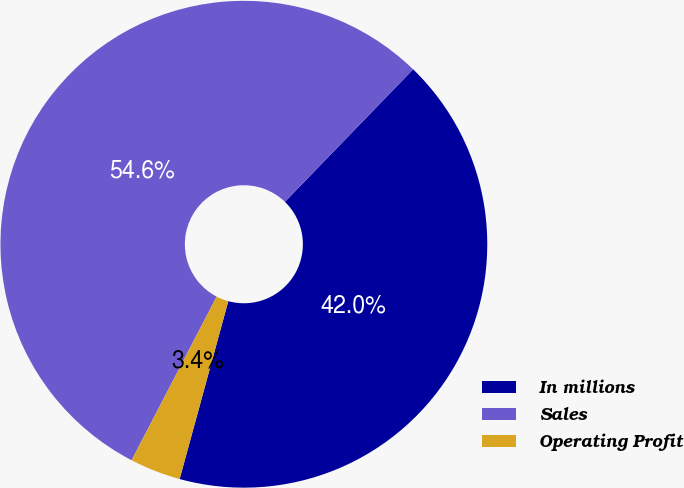Convert chart. <chart><loc_0><loc_0><loc_500><loc_500><pie_chart><fcel>In millions<fcel>Sales<fcel>Operating Profit<nl><fcel>42.01%<fcel>54.61%<fcel>3.38%<nl></chart> 